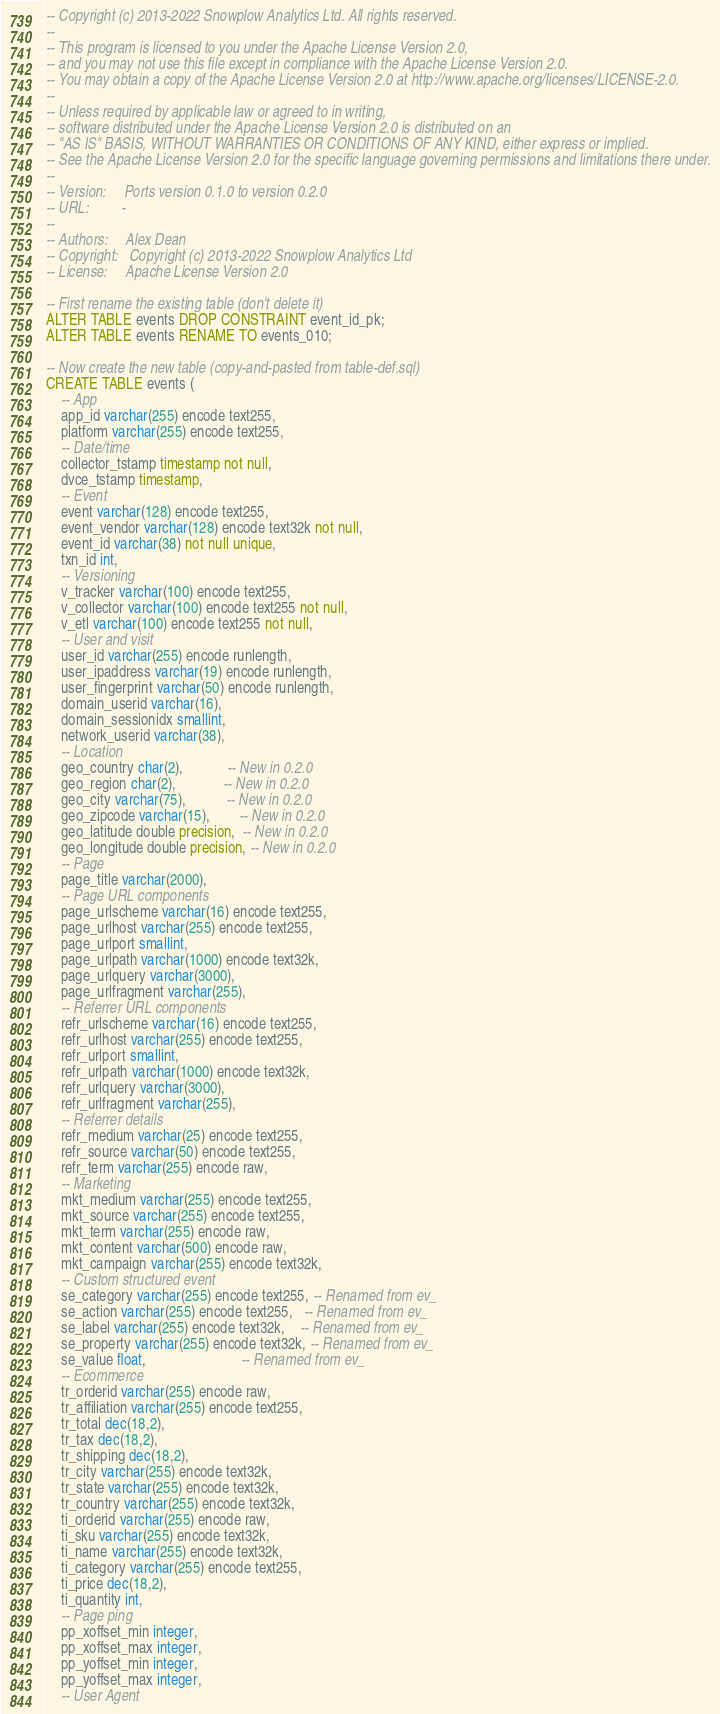<code> <loc_0><loc_0><loc_500><loc_500><_SQL_>-- Copyright (c) 2013-2022 Snowplow Analytics Ltd. All rights reserved.
--
-- This program is licensed to you under the Apache License Version 2.0,
-- and you may not use this file except in compliance with the Apache License Version 2.0.
-- You may obtain a copy of the Apache License Version 2.0 at http://www.apache.org/licenses/LICENSE-2.0.
--
-- Unless required by applicable law or agreed to in writing,
-- software distributed under the Apache License Version 2.0 is distributed on an
-- "AS IS" BASIS, WITHOUT WARRANTIES OR CONDITIONS OF ANY KIND, either express or implied.
-- See the Apache License Version 2.0 for the specific language governing permissions and limitations there under.
--
-- Version:     Ports version 0.1.0 to version 0.2.0
-- URL:         -
--
-- Authors:     Alex Dean
-- Copyright:   Copyright (c) 2013-2022 Snowplow Analytics Ltd
-- License:     Apache License Version 2.0

-- First rename the existing table (don't delete it)
ALTER TABLE events DROP CONSTRAINT event_id_pk;
ALTER TABLE events RENAME TO events_010;

-- Now create the new table (copy-and-pasted from table-def.sql)
CREATE TABLE events (
	-- App
	app_id varchar(255) encode text255,
	platform varchar(255) encode text255,
	-- Date/time
	collector_tstamp timestamp not null,
	dvce_tstamp timestamp,
	-- Event
	event varchar(128) encode text255,
	event_vendor varchar(128) encode text32k not null,
	event_id varchar(38) not null unique,
	txn_id int,
	-- Versioning
	v_tracker varchar(100) encode text255,
	v_collector varchar(100) encode text255 not null,
	v_etl varchar(100) encode text255 not null,
	-- User and visit
	user_id varchar(255) encode runlength,
	user_ipaddress varchar(19) encode runlength,
	user_fingerprint varchar(50) encode runlength,
	domain_userid varchar(16),
	domain_sessionidx smallint,
	network_userid varchar(38),
	-- Location
	geo_country char(2),            -- New in 0.2.0
	geo_region char(2),             -- New in 0.2.0
	geo_city varchar(75),           -- New in 0.2.0
	geo_zipcode varchar(15),        -- New in 0.2.0
	geo_latitude double precision,  -- New in 0.2.0
	geo_longitude double precision, -- New in 0.2.0
	-- Page
	page_title varchar(2000),
	-- Page URL components
	page_urlscheme varchar(16) encode text255,
	page_urlhost varchar(255) encode text255,
	page_urlport smallint,
	page_urlpath varchar(1000) encode text32k,
	page_urlquery varchar(3000),
	page_urlfragment varchar(255),
	-- Referrer URL components
	refr_urlscheme varchar(16) encode text255,
	refr_urlhost varchar(255) encode text255,
	refr_urlport smallint,
	refr_urlpath varchar(1000) encode text32k,
	refr_urlquery varchar(3000),
	refr_urlfragment varchar(255),
	-- Referrer details
	refr_medium varchar(25) encode text255,
	refr_source varchar(50) encode text255,
	refr_term varchar(255) encode raw,
	-- Marketing
	mkt_medium varchar(255) encode text255,
	mkt_source varchar(255) encode text255,
	mkt_term varchar(255) encode raw,
	mkt_content varchar(500) encode raw,
	mkt_campaign varchar(255) encode text32k,
	-- Custom structured event
	se_category varchar(255) encode text255, -- Renamed from ev_
	se_action varchar(255) encode text255,   -- Renamed from ev_
	se_label varchar(255) encode text32k,    -- Renamed from ev_
	se_property varchar(255) encode text32k, -- Renamed from ev_
	se_value float,                          -- Renamed from ev_
	-- Ecommerce
	tr_orderid varchar(255) encode raw,
	tr_affiliation varchar(255) encode text255,
	tr_total dec(18,2),
	tr_tax dec(18,2),
	tr_shipping dec(18,2),
	tr_city varchar(255) encode text32k,
	tr_state varchar(255) encode text32k,
	tr_country varchar(255) encode text32k,
	ti_orderid varchar(255) encode raw,
	ti_sku varchar(255) encode text32k,
	ti_name varchar(255) encode text32k,
	ti_category varchar(255) encode text255,
	ti_price dec(18,2),
	ti_quantity int,
	-- Page ping
	pp_xoffset_min integer,
	pp_xoffset_max integer,
	pp_yoffset_min integer,
	pp_yoffset_max integer,
	-- User Agent</code> 